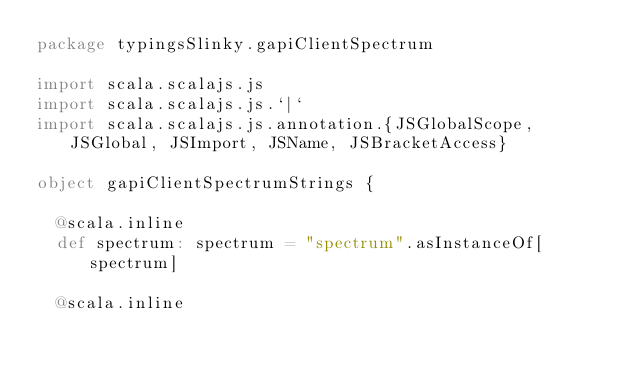Convert code to text. <code><loc_0><loc_0><loc_500><loc_500><_Scala_>package typingsSlinky.gapiClientSpectrum

import scala.scalajs.js
import scala.scalajs.js.`|`
import scala.scalajs.js.annotation.{JSGlobalScope, JSGlobal, JSImport, JSName, JSBracketAccess}

object gapiClientSpectrumStrings {
  
  @scala.inline
  def spectrum: spectrum = "spectrum".asInstanceOf[spectrum]
  
  @scala.inline</code> 